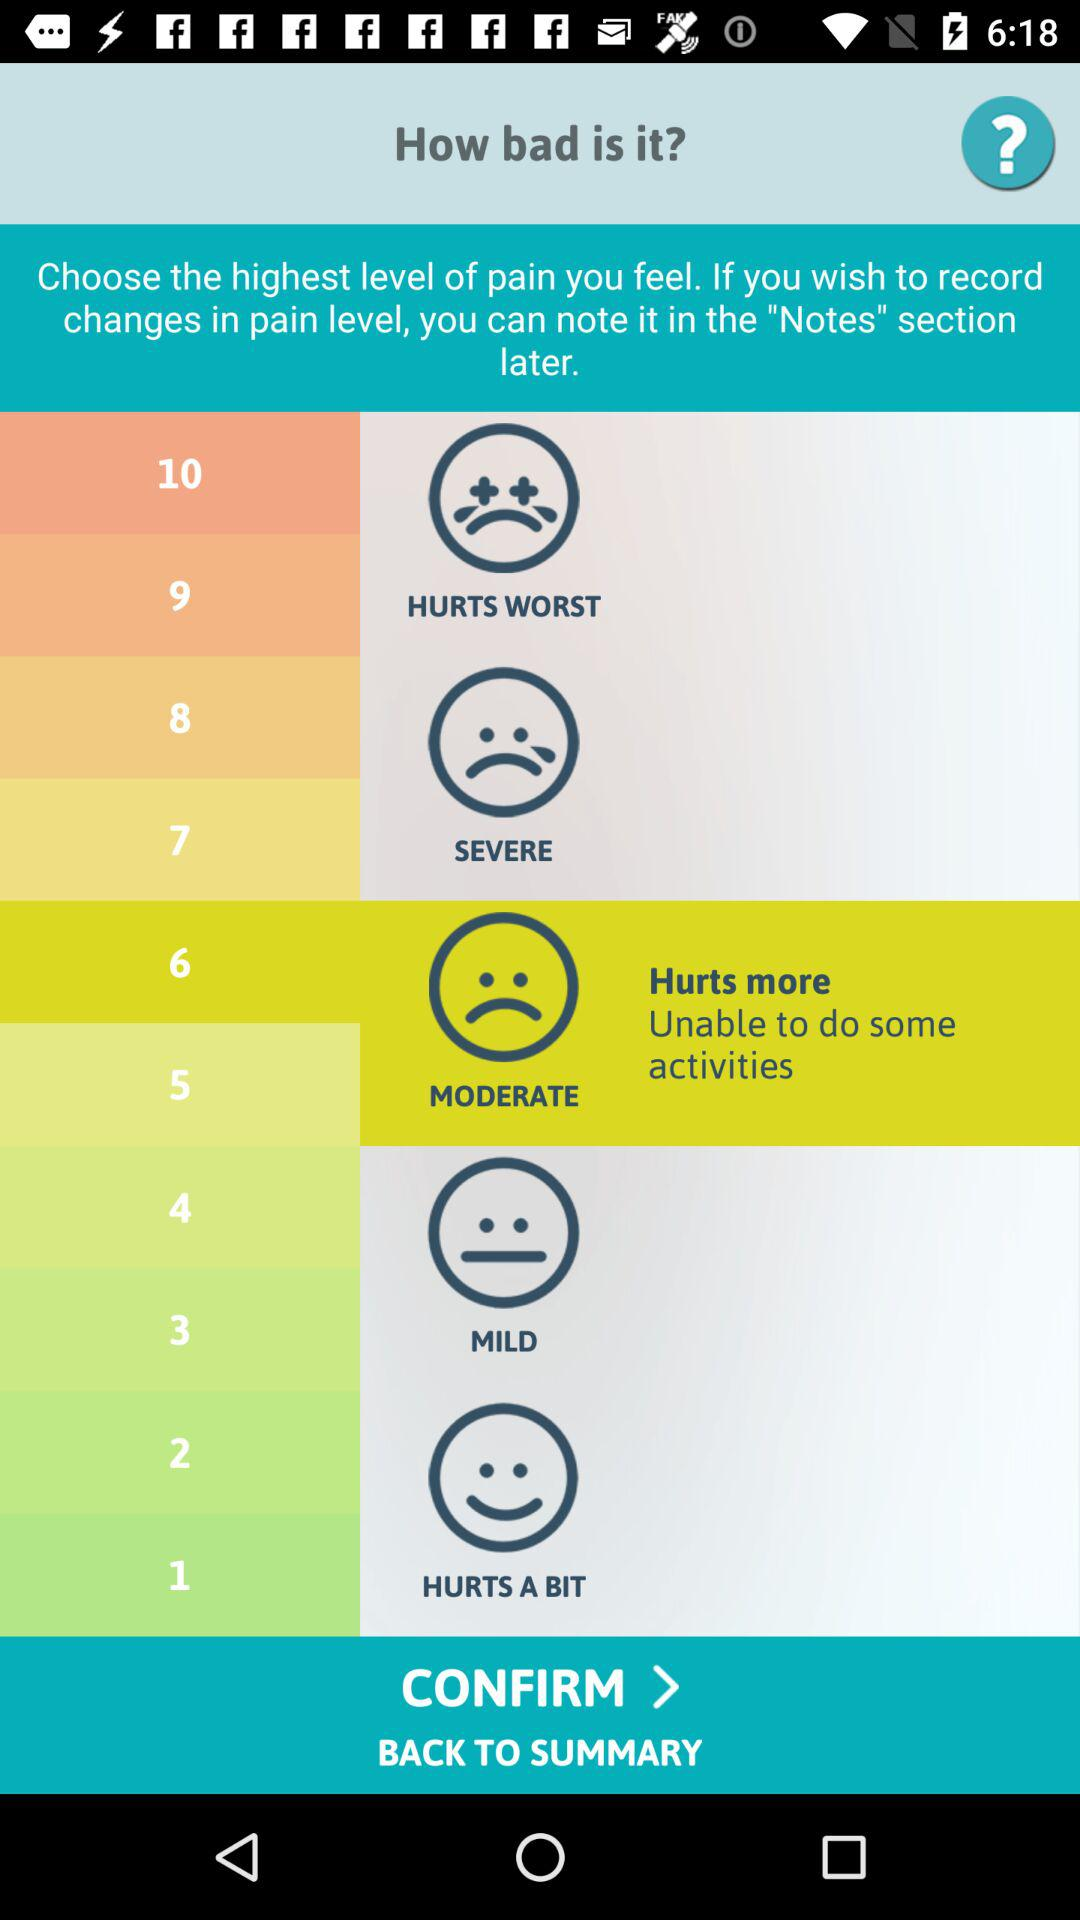How many levels of pain are there in total?
Answer the question using a single word or phrase. 10 